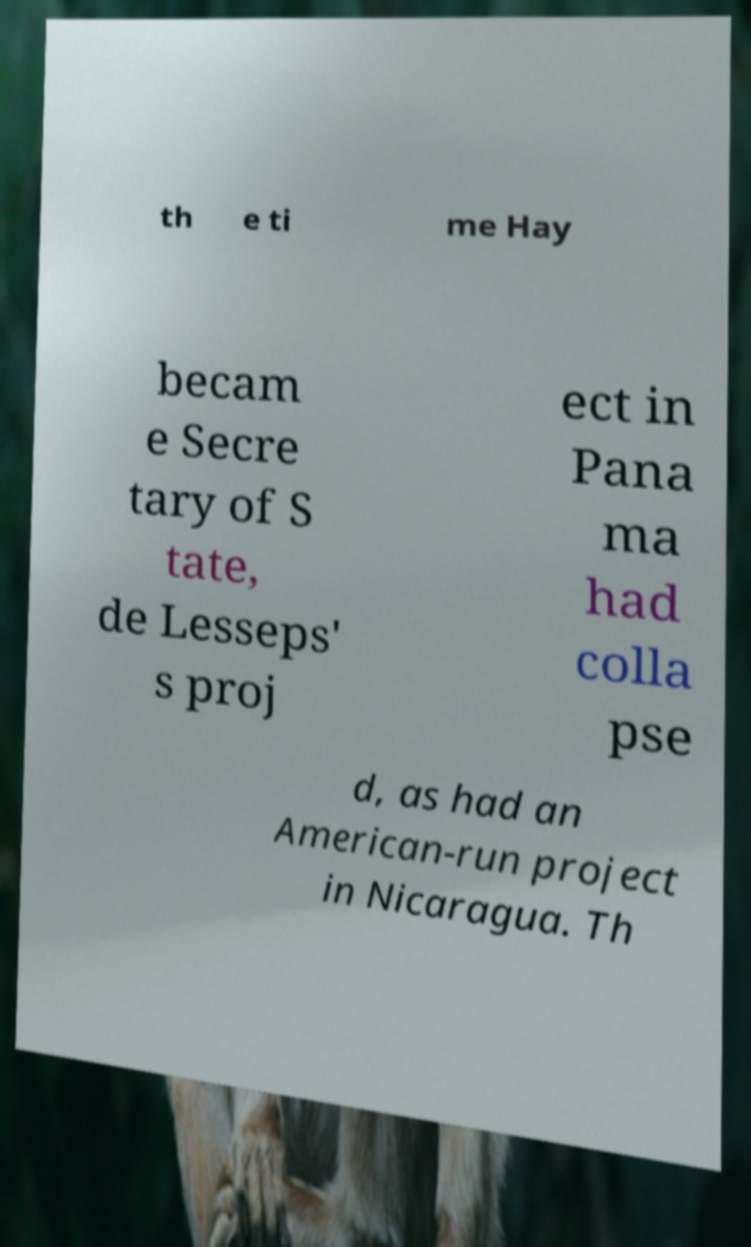What messages or text are displayed in this image? I need them in a readable, typed format. th e ti me Hay becam e Secre tary of S tate, de Lesseps' s proj ect in Pana ma had colla pse d, as had an American-run project in Nicaragua. Th 